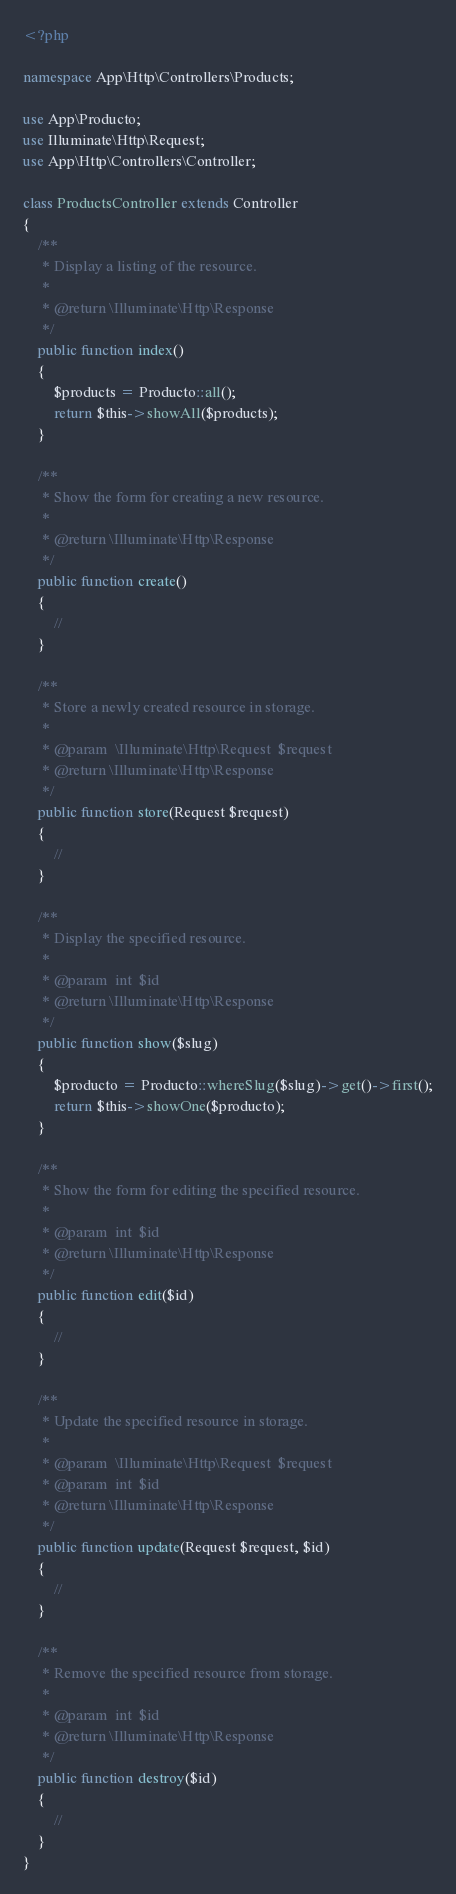<code> <loc_0><loc_0><loc_500><loc_500><_PHP_><?php

namespace App\Http\Controllers\Products;

use App\Producto;
use Illuminate\Http\Request;
use App\Http\Controllers\Controller;

class ProductsController extends Controller
{
    /**
     * Display a listing of the resource.
     *
     * @return \Illuminate\Http\Response
     */
    public function index()
    {
        $products = Producto::all();
        return $this->showAll($products);
    }

    /**
     * Show the form for creating a new resource.
     *
     * @return \Illuminate\Http\Response
     */
    public function create()
    {
        //
    }

    /**
     * Store a newly created resource in storage.
     *
     * @param  \Illuminate\Http\Request  $request
     * @return \Illuminate\Http\Response
     */
    public function store(Request $request)
    {
        //
    }

    /**
     * Display the specified resource.
     *
     * @param  int  $id
     * @return \Illuminate\Http\Response
     */
    public function show($slug)
    {
        $producto = Producto::whereSlug($slug)->get()->first();
        return $this->showOne($producto);
    }

    /**
     * Show the form for editing the specified resource.
     *
     * @param  int  $id
     * @return \Illuminate\Http\Response
     */
    public function edit($id)
    {
        //
    }

    /**
     * Update the specified resource in storage.
     *
     * @param  \Illuminate\Http\Request  $request
     * @param  int  $id
     * @return \Illuminate\Http\Response
     */
    public function update(Request $request, $id)
    {
        //
    }

    /**
     * Remove the specified resource from storage.
     *
     * @param  int  $id
     * @return \Illuminate\Http\Response
     */
    public function destroy($id)
    {
        //
    }
}
</code> 